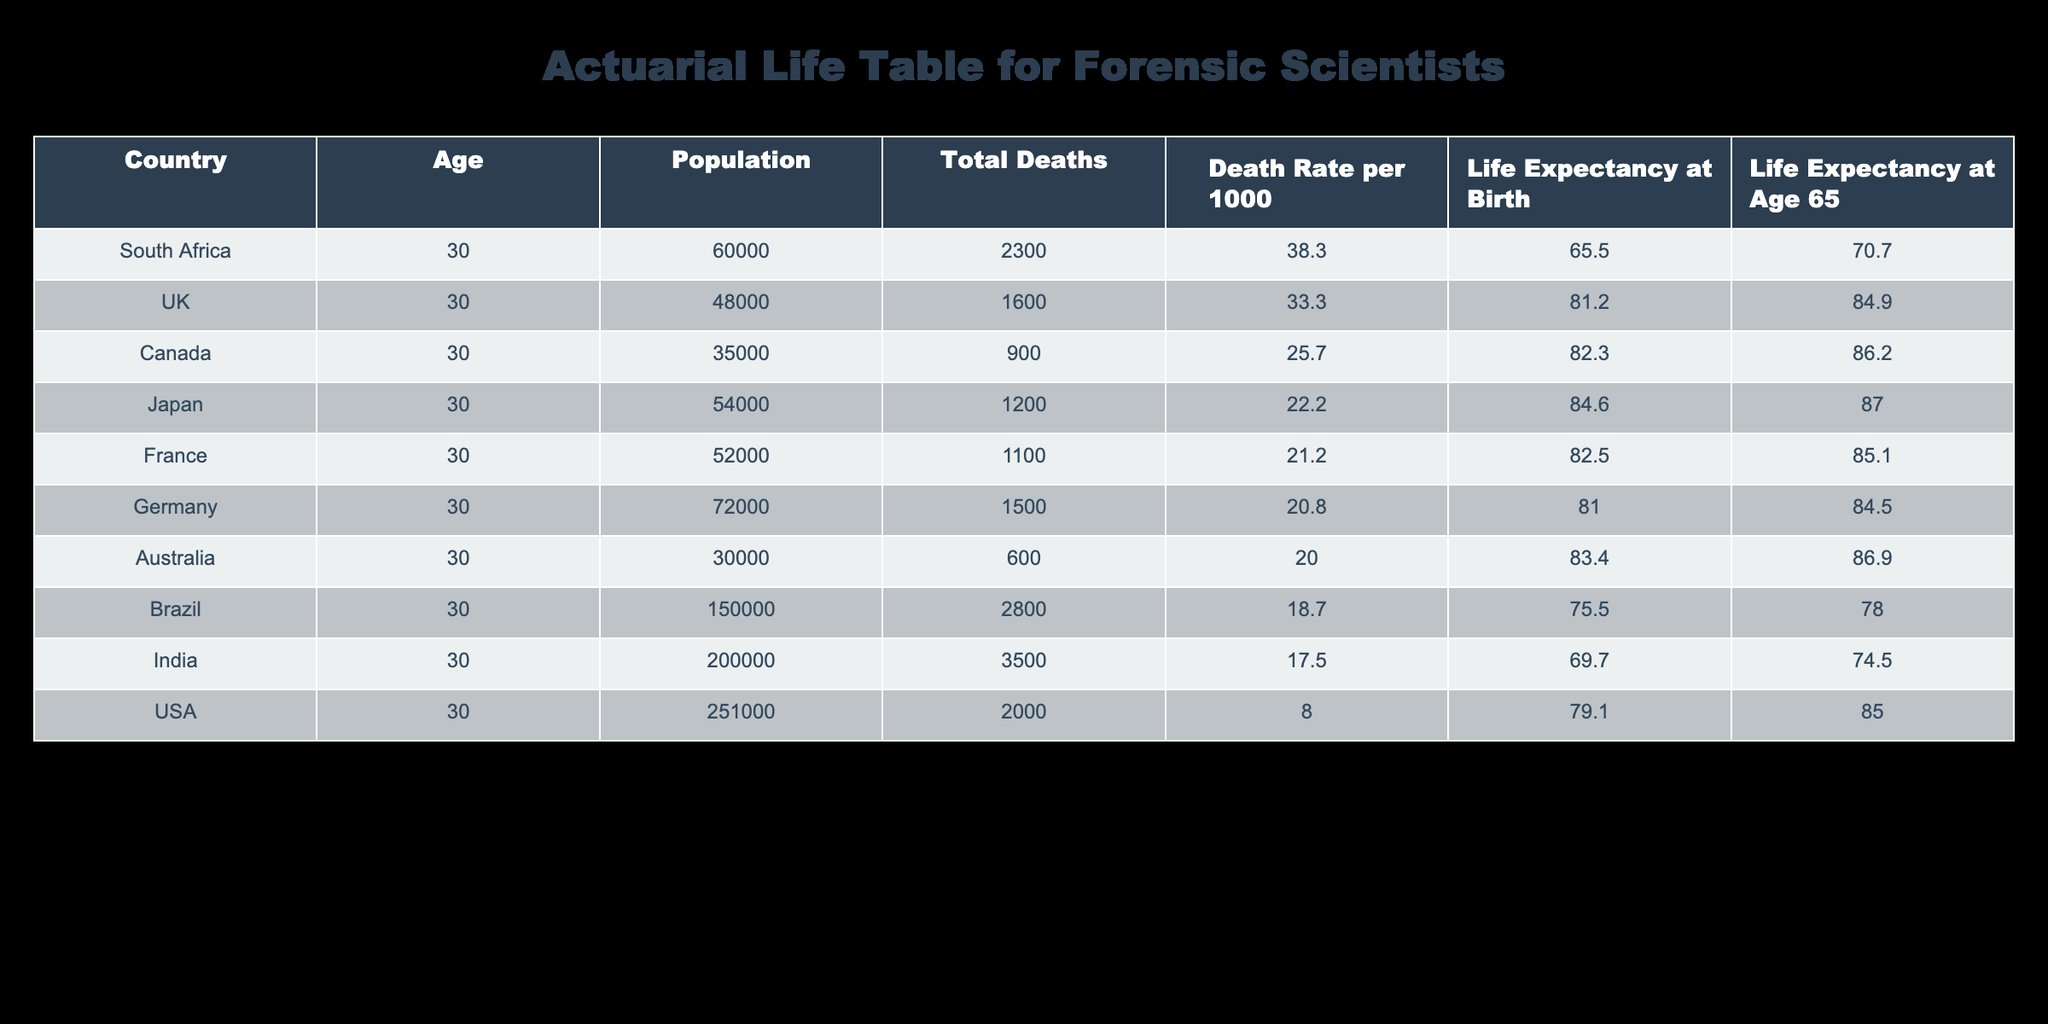What is the death rate per 1000 for South Africa? Referring to the row for South Africa in the table, the death rate is listed as 38.3 per 1000 population.
Answer: 38.3 What country has the highest life expectancy at birth? By checking the 'Life Expectancy at Birth' column, Japan has the highest value at 84.6 years.
Answer: Japan What is the average life expectancy at age 65 for the countries listed? Adding the life expectancy at age 65 values: 85.0 + 84.5 + 87.0 + 86.2 + 84.9 + 86.9 + 74.5 + 78.0 + 70.7 + 85.1 = 858.8. There are 10 countries, so the average is 858.8 / 10 = 85.88 years.
Answer: 85.88 Is the death rate per 1000 in Canada higher than that in the UK? Checking the respective death rates: Canada has 25.7 per 1000, while the UK has 33.3 per 1000. Since 25.7 is less than 33.3, the statement is false.
Answer: No What is the difference in life expectancy at birth between the USA and Germany? The life expectancy at birth for the USA is 79.1 years and for Germany, it is 81.0 years. The difference is 81.0 - 79.1 = 1.9 years.
Answer: 1.9 Which country has both a high death rate and low life expectancy at birth? Checking the countries in the table, South Africa has the highest death rate (38.3) and the lowest life expectancy at birth (65.5). This indicates poor health outcomes.
Answer: South Africa What are the total deaths in Brazil, and how does it compare to India? Total deaths in Brazil are 2800, while in India they're 3500. Comparing these, India has 700 more deaths than Brazil (3500 - 2800 = 700).
Answer: India has 700 more deaths than Brazil Which country has the lowest life expectancy at age 65? By examining the 'Life Expectancy at Age 65' column, South Africa has the lowest value at 70.7 years.
Answer: South Africa 